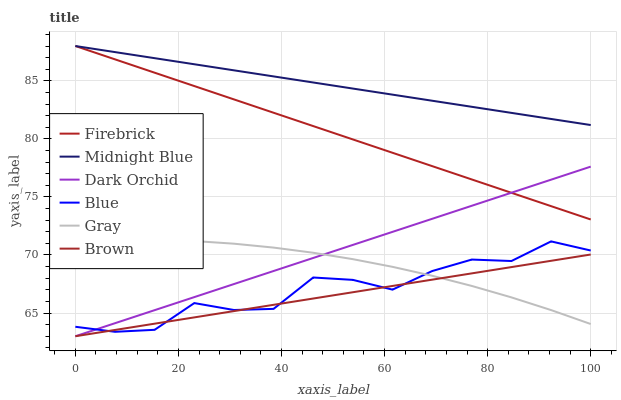Does Brown have the minimum area under the curve?
Answer yes or no. Yes. Does Midnight Blue have the maximum area under the curve?
Answer yes or no. Yes. Does Gray have the minimum area under the curve?
Answer yes or no. No. Does Gray have the maximum area under the curve?
Answer yes or no. No. Is Brown the smoothest?
Answer yes or no. Yes. Is Blue the roughest?
Answer yes or no. Yes. Is Gray the smoothest?
Answer yes or no. No. Is Gray the roughest?
Answer yes or no. No. Does Brown have the lowest value?
Answer yes or no. Yes. Does Gray have the lowest value?
Answer yes or no. No. Does Firebrick have the highest value?
Answer yes or no. Yes. Does Gray have the highest value?
Answer yes or no. No. Is Blue less than Firebrick?
Answer yes or no. Yes. Is Midnight Blue greater than Dark Orchid?
Answer yes or no. Yes. Does Gray intersect Dark Orchid?
Answer yes or no. Yes. Is Gray less than Dark Orchid?
Answer yes or no. No. Is Gray greater than Dark Orchid?
Answer yes or no. No. Does Blue intersect Firebrick?
Answer yes or no. No. 